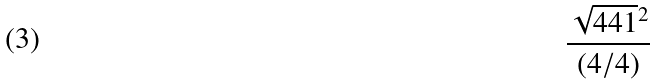Convert formula to latex. <formula><loc_0><loc_0><loc_500><loc_500>\frac { \sqrt { 4 4 1 } ^ { 2 } } { ( 4 / 4 ) }</formula> 